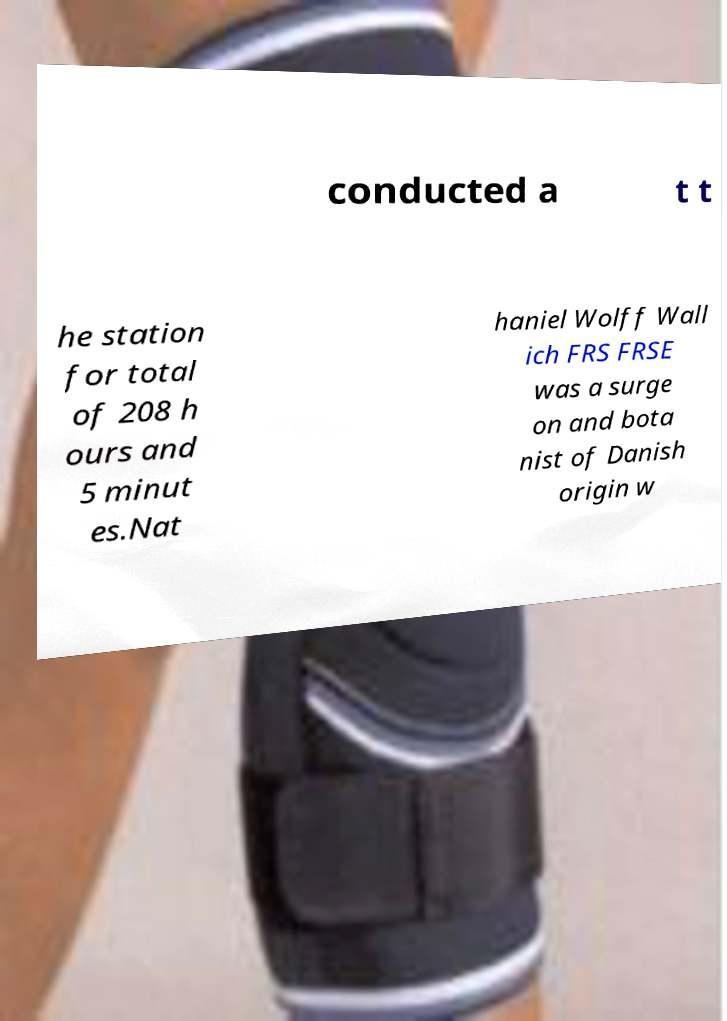Can you accurately transcribe the text from the provided image for me? conducted a t t he station for total of 208 h ours and 5 minut es.Nat haniel Wolff Wall ich FRS FRSE was a surge on and bota nist of Danish origin w 